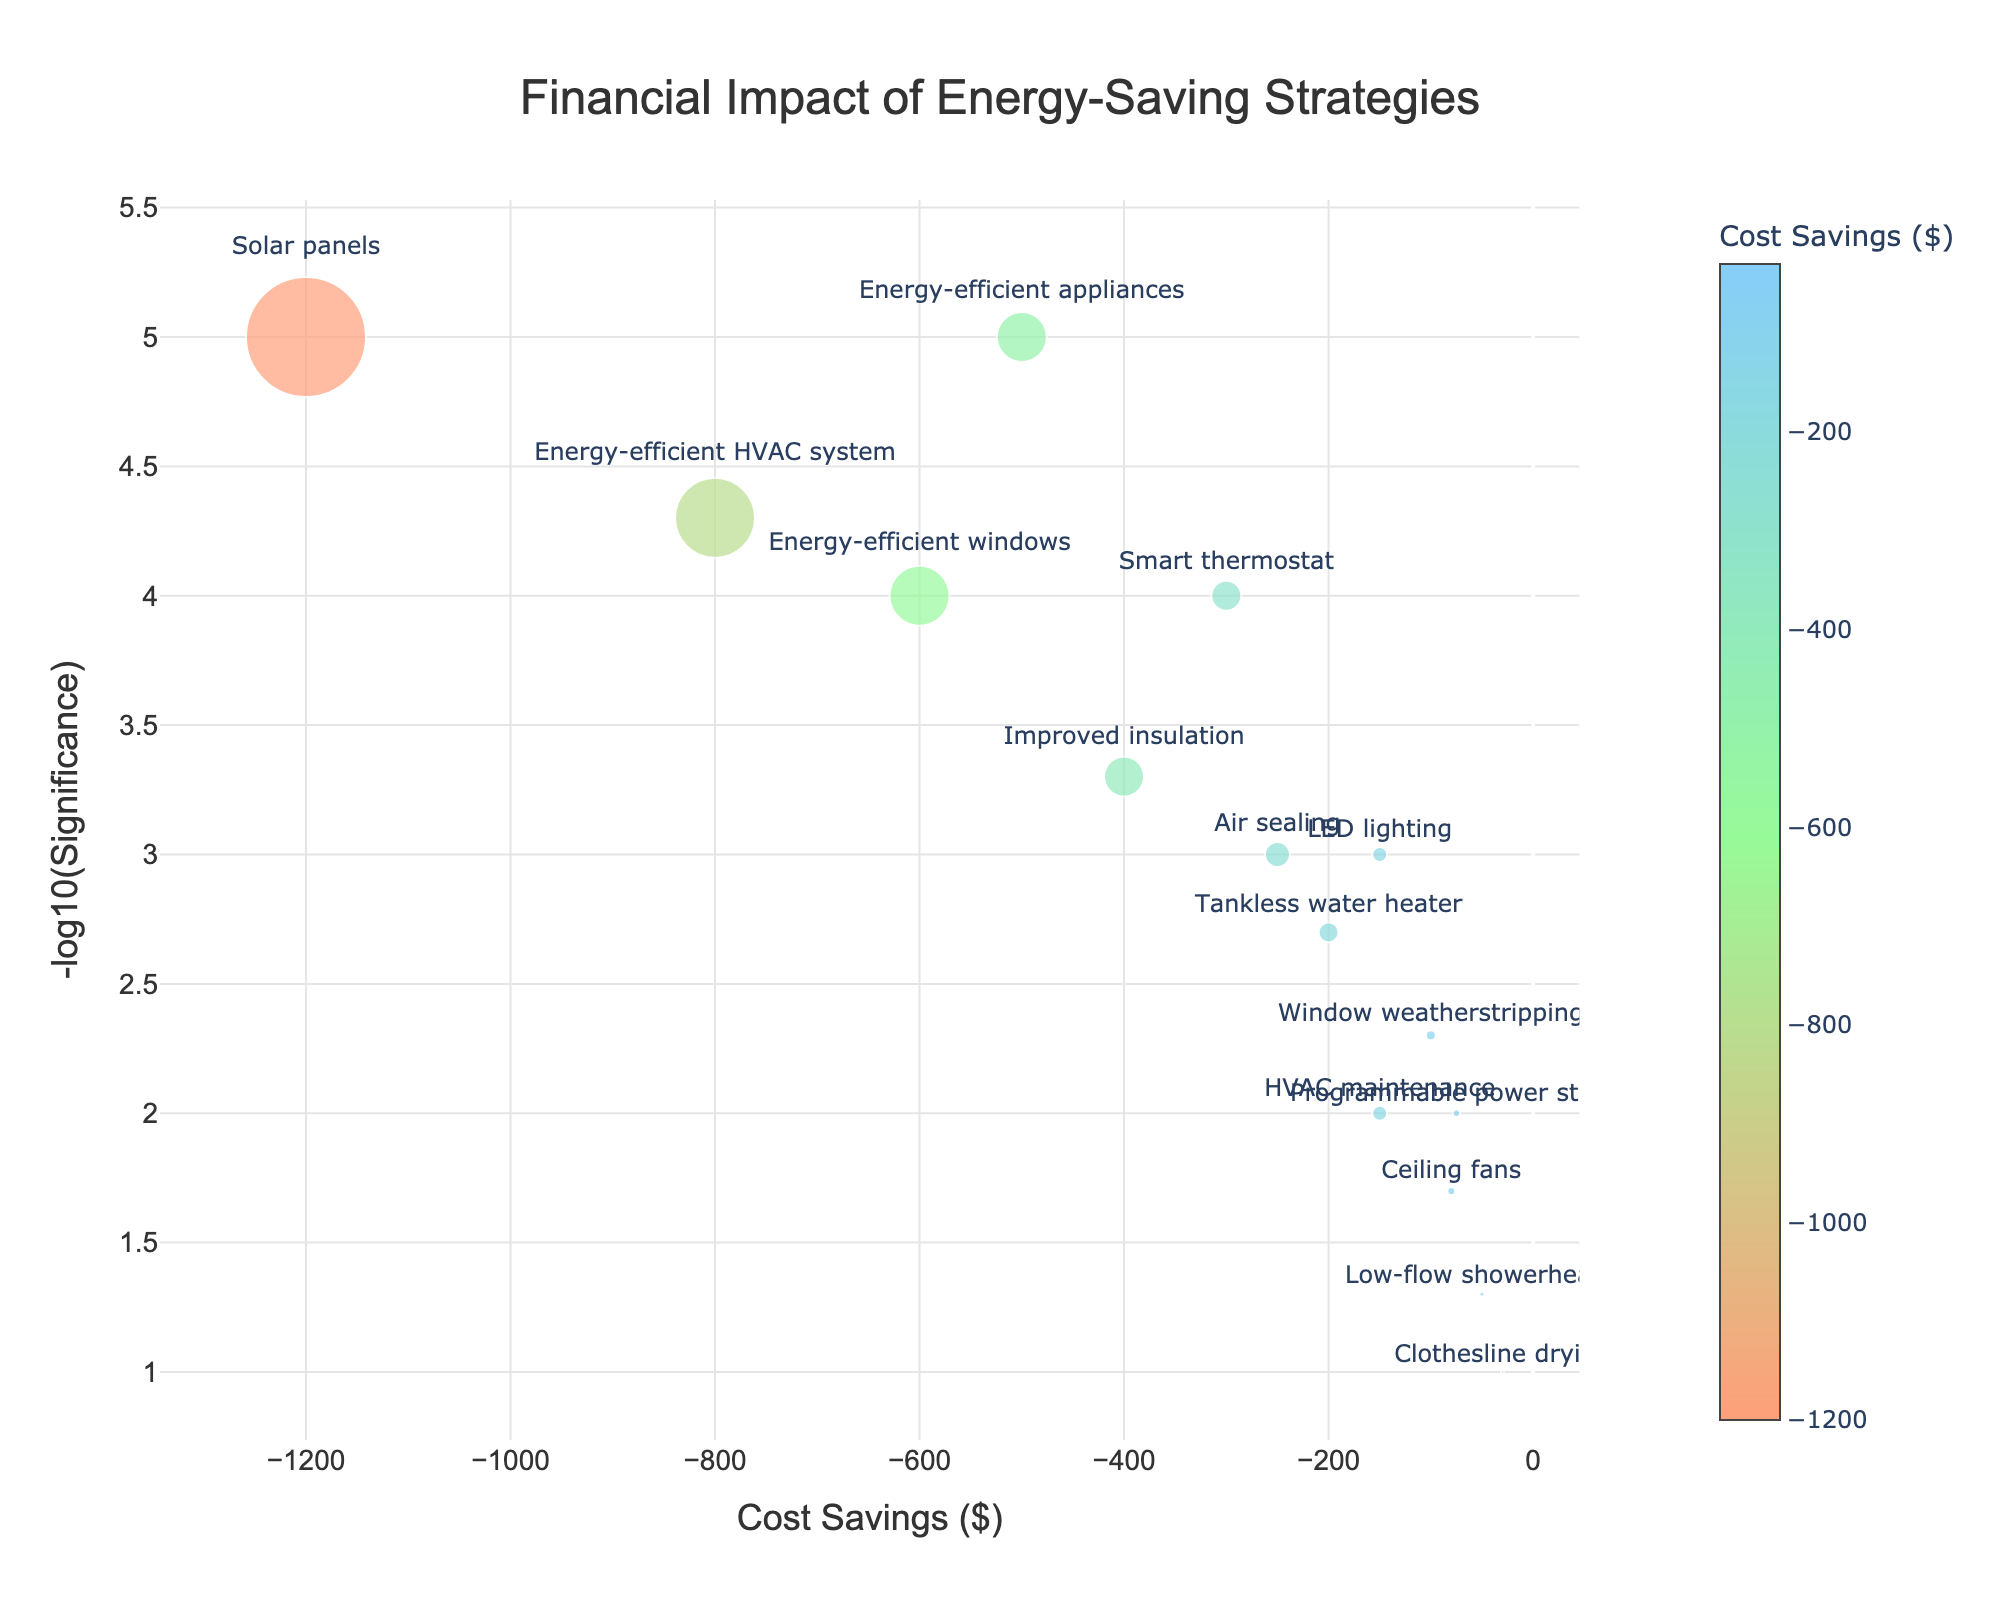What is the title of the plot? The title can be found at the top of the plot, centered and usually in a larger font size. It provides a concise description of what the plot represents.
Answer: Financial Impact of Energy-Saving Strategies How many energy-saving strategies are represented in the plot? Each marker (dot) on the plot corresponds to one energy-saving strategy. By counting the markers, we can determine the number of strategies.
Answer: 14 Which energy-saving strategy is associated with the highest cost savings? The highest cost savings correspond to the point farthest to the left on the x-axis (cost savings in negative dollars). By identifying this point, the associated strategy can be determined.
Answer: Solar panels What is the significance value associated with LED lighting? Hovering over the point representing LED lighting will show a hovertext box with details including the significance value. The y-axis also represents the negative log10 transformation of significance, which can be inversely transformed if needed.
Answer: 0.001 Which strategy has the smallest marker size and what does this represent? The marker size is proportional to the negative of the cost savings. The smallest size represents the strategy with the least cost savings. By identifying the smallest marker, we can note down the strategy it represents.
Answer: Clothesline drying How do the cost savings from improved insulation compare with those from air sealing? Locate the points for both improved insulation and air sealing on the x-axis. The positions on the x-axis will tell you which strategy offers greater cost savings (the point further to the left).
Answer: Improved insulation offers greater cost savings than air sealing What are the cost savings for the least significant strategy? The least significant strategy can be identified by finding the point with the smallest value on the y-axis (-log10(significance)). The cost savings can be read directly from the x-axis for this point.
Answer: Clothesline drying with -30 dollars What is the range of cost savings across all strategies? Identify the maximum and minimum x-values (cost savings) from the plot. The range is the difference between these two values.
Answer: -1200 to -30 dollars Which strategy has the highest -log10(Significance) value? The highest -log10(Significance) value corresponds to the point highest up on the y-axis. Identify this point and determine the associated strategy.
Answer: Solar panels Are there any strategies with the same cost savings but different levels of significance? Observe if any points are aligned vertically (same x-value) but positioned differently on the y-axis to find strategies with identical costs but varying significance levels.
Answer: No strategies have the same cost savings 